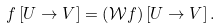<formula> <loc_0><loc_0><loc_500><loc_500>f \left [ U \to V \right ] = \left ( \mathcal { W } f \right ) \left [ U \to V \right ] .</formula> 